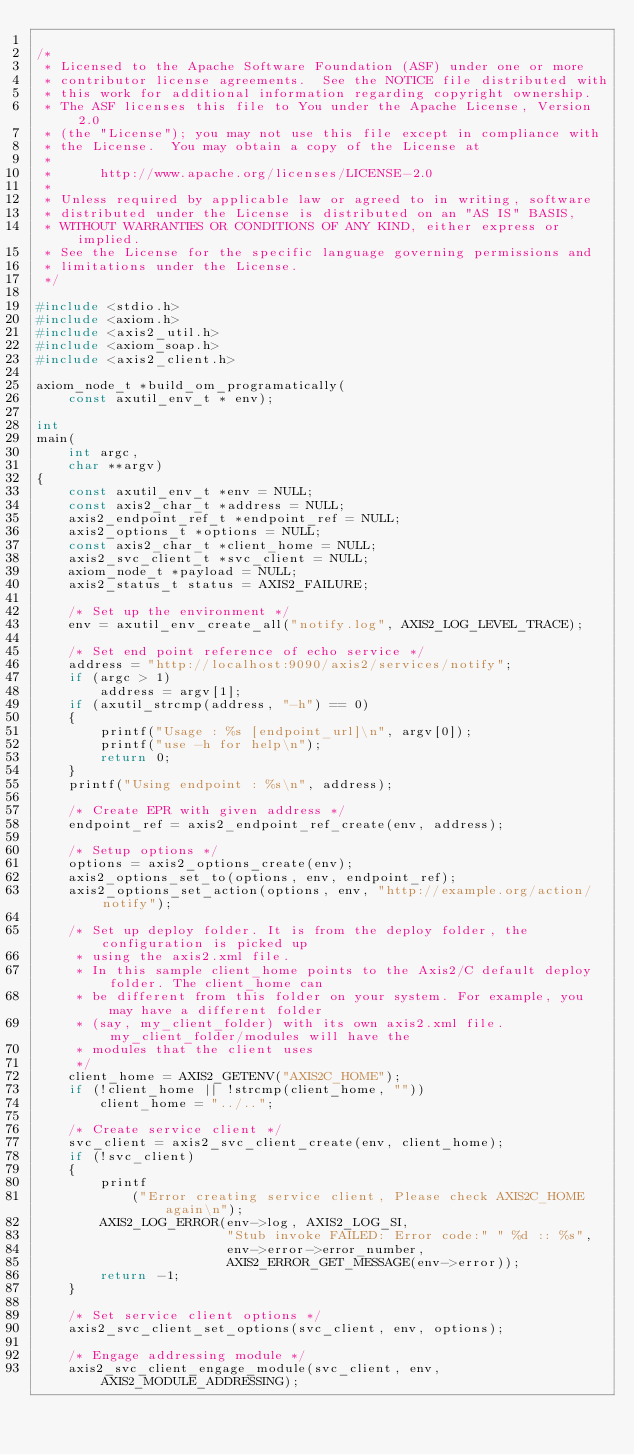<code> <loc_0><loc_0><loc_500><loc_500><_C_>
/*
 * Licensed to the Apache Software Foundation (ASF) under one or more
 * contributor license agreements.  See the NOTICE file distributed with
 * this work for additional information regarding copyright ownership.
 * The ASF licenses this file to You under the Apache License, Version 2.0
 * (the "License"); you may not use this file except in compliance with
 * the License.  You may obtain a copy of the License at
 *
 *      http://www.apache.org/licenses/LICENSE-2.0
 *
 * Unless required by applicable law or agreed to in writing, software
 * distributed under the License is distributed on an "AS IS" BASIS,
 * WITHOUT WARRANTIES OR CONDITIONS OF ANY KIND, either express or implied.
 * See the License for the specific language governing permissions and
 * limitations under the License.
 */

#include <stdio.h>
#include <axiom.h>
#include <axis2_util.h>
#include <axiom_soap.h>
#include <axis2_client.h>

axiom_node_t *build_om_programatically(
    const axutil_env_t * env);

int
main(
    int argc,
    char **argv)
{
    const axutil_env_t *env = NULL;
    const axis2_char_t *address = NULL;
    axis2_endpoint_ref_t *endpoint_ref = NULL;
    axis2_options_t *options = NULL;
    const axis2_char_t *client_home = NULL;
    axis2_svc_client_t *svc_client = NULL;
    axiom_node_t *payload = NULL;
    axis2_status_t status = AXIS2_FAILURE;

    /* Set up the environment */
    env = axutil_env_create_all("notify.log", AXIS2_LOG_LEVEL_TRACE);

    /* Set end point reference of echo service */
    address = "http://localhost:9090/axis2/services/notify";
    if (argc > 1)
        address = argv[1];
    if (axutil_strcmp(address, "-h") == 0)
    {
        printf("Usage : %s [endpoint_url]\n", argv[0]);
        printf("use -h for help\n");
        return 0;
    }
    printf("Using endpoint : %s\n", address);

    /* Create EPR with given address */
    endpoint_ref = axis2_endpoint_ref_create(env, address);

    /* Setup options */
    options = axis2_options_create(env);
    axis2_options_set_to(options, env, endpoint_ref);
    axis2_options_set_action(options, env, "http://example.org/action/notify");

    /* Set up deploy folder. It is from the deploy folder, the configuration is picked up
     * using the axis2.xml file.
     * In this sample client_home points to the Axis2/C default deploy folder. The client_home can 
     * be different from this folder on your system. For example, you may have a different folder 
     * (say, my_client_folder) with its own axis2.xml file. my_client_folder/modules will have the 
     * modules that the client uses
     */
    client_home = AXIS2_GETENV("AXIS2C_HOME");
    if (!client_home || !strcmp(client_home, ""))
        client_home = "../..";

    /* Create service client */
    svc_client = axis2_svc_client_create(env, client_home);
    if (!svc_client)
    {
        printf
            ("Error creating service client, Please check AXIS2C_HOME again\n");
        AXIS2_LOG_ERROR(env->log, AXIS2_LOG_SI,
                        "Stub invoke FAILED: Error code:" " %d :: %s",
                        env->error->error_number,
                        AXIS2_ERROR_GET_MESSAGE(env->error));
        return -1;
    }

    /* Set service client options */
    axis2_svc_client_set_options(svc_client, env, options);

    /* Engage addressing module */
    axis2_svc_client_engage_module(svc_client, env, AXIS2_MODULE_ADDRESSING);
</code> 